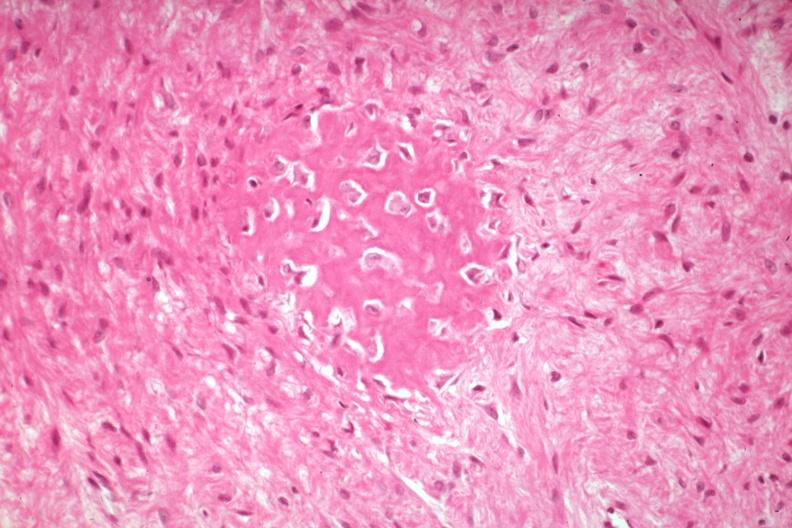does this image show high excessive fibrous callus with focal osteoid deposition with osteoblasts?
Answer the question using a single word or phrase. Yes 